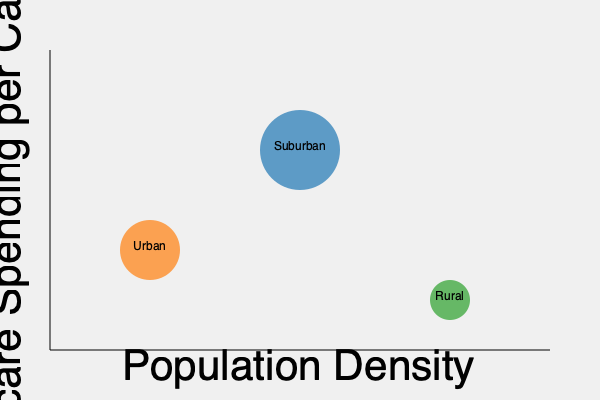Based on the bubble chart showing healthcare spending per capita versus population density for different demographic areas, which conclusion can be drawn about the distribution of healthcare resources? To analyze this bubble chart and draw conclusions about the distribution of healthcare resources, we need to consider three key factors:

1. Position on the x-axis: This represents population density, with higher values indicating more densely populated areas.
2. Position on the y-axis: This shows healthcare spending per capita, with higher values indicating more spending.
3. Size of the bubble: This typically represents the total population in each demographic area.

Let's examine each demographic area:

1. Urban:
   - Moderate population density
   - Moderate healthcare spending per capita
   - Moderate population size

2. Suburban:
   - Higher population density than urban areas
   - Highest healthcare spending per capita
   - Largest population size

3. Rural:
   - Lowest population density
   - Lowest healthcare spending per capita
   - Smallest population size

From this analysis, we can conclude that suburban areas have the highest concentration of healthcare resources. They have the highest per capita spending and the largest population, suggesting that these areas receive a disproportionate share of healthcare resources compared to urban and rural areas.

Rural areas appear to be the most underserved, with the lowest per capita spending and smallest population size, indicating a potential healthcare disparity.

Urban areas fall in the middle, suggesting a more balanced distribution of resources relative to their population density and size.

This distribution highlights a potential mismatch between healthcare needs and resource allocation, particularly for rural areas which may face challenges in accessing adequate healthcare services.
Answer: Suburban areas receive a disproportionate share of healthcare resources, while rural areas appear underserved, indicating healthcare disparities across demographic regions. 